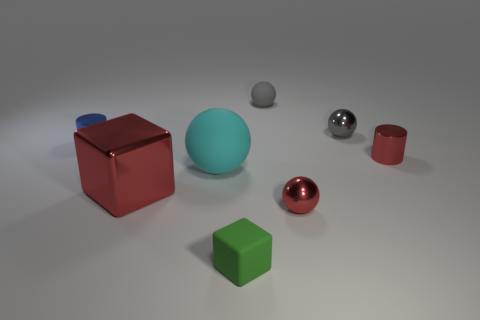The red thing on the right side of the small shiny sphere that is behind the cyan object is what shape?
Offer a terse response. Cylinder. What number of other objects are there of the same material as the tiny blue object?
Provide a succinct answer. 4. Do the red cylinder and the sphere that is on the right side of the red sphere have the same material?
Provide a short and direct response. Yes. What number of things are either things that are behind the small gray shiny sphere or small gray rubber balls that are right of the red shiny block?
Ensure brevity in your answer.  1. How many other things are there of the same color as the small matte block?
Make the answer very short. 0. Are there more large things to the left of the cyan ball than cyan objects that are on the right side of the green cube?
Your response must be concise. Yes. Is there any other thing that has the same size as the red metal cube?
Make the answer very short. Yes. How many cubes are either small metal objects or cyan objects?
Your answer should be very brief. 0. How many things are either shiny cylinders that are right of the small blue object or red metal cylinders?
Provide a succinct answer. 1. The small red object in front of the cylinder that is on the right side of the small rubber object that is behind the small blue shiny object is what shape?
Ensure brevity in your answer.  Sphere. 